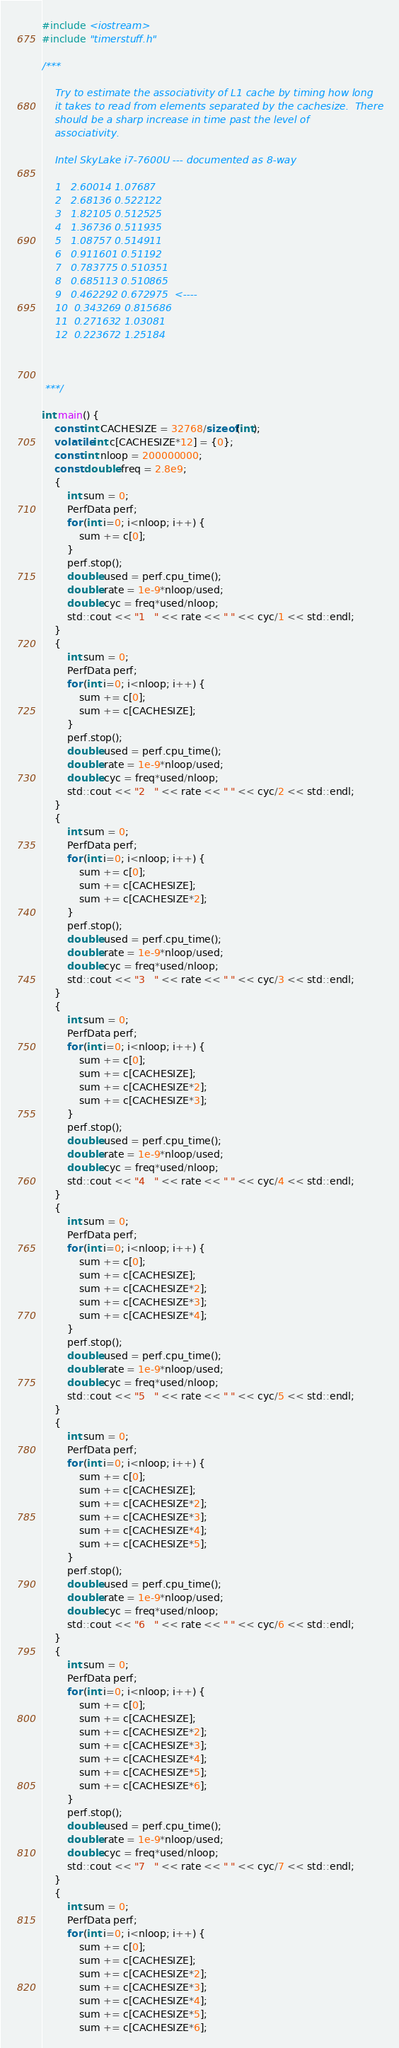Convert code to text. <code><loc_0><loc_0><loc_500><loc_500><_C++_>#include <iostream>
#include "timerstuff.h"

/***

    Try to estimate the associativity of L1 cache by timing how long
    it takes to read from elements separated by the cachesize.  There
    should be a sharp increase in time past the level of
    associativity.

    Intel SkyLake i7-7600U --- documented as 8-way

    1   2.60014 1.07687
    2   2.68136 0.522122
    3   1.82105 0.512525
    4   1.36736 0.511935
    5   1.08757 0.514911
    6   0.911601 0.51192
    7   0.783775 0.510351
    8   0.685113 0.510865
    9   0.462292 0.672975  <----
    10  0.343269 0.815686
    11  0.271632 1.03081
    12  0.223672 1.25184

    

 ***/

int main() {
    const int CACHESIZE = 32768/sizeof(int);
    volatile int c[CACHESIZE*12] = {0};
    const int nloop = 200000000;
    const double freq = 2.8e9;
    {
        int sum = 0;
        PerfData perf;
        for (int i=0; i<nloop; i++) {
            sum += c[0];
        }
        perf.stop();
        double used = perf.cpu_time();
        double rate = 1e-9*nloop/used;
        double cyc = freq*used/nloop;
        std::cout << "1   " << rate << " " << cyc/1 << std::endl;
    }
    {
        int sum = 0;
        PerfData perf;
        for (int i=0; i<nloop; i++) {
            sum += c[0];
            sum += c[CACHESIZE];
        }
        perf.stop();
        double used = perf.cpu_time();
        double rate = 1e-9*nloop/used;
        double cyc = freq*used/nloop;
        std::cout << "2   " << rate << " " << cyc/2 << std::endl;
    }
    {
        int sum = 0;
        PerfData perf;
        for (int i=0; i<nloop; i++) {
            sum += c[0];
            sum += c[CACHESIZE];
            sum += c[CACHESIZE*2];
        }
        perf.stop();
        double used = perf.cpu_time();
        double rate = 1e-9*nloop/used;
        double cyc = freq*used/nloop;
        std::cout << "3   " << rate << " " << cyc/3 << std::endl;
    }
    {
        int sum = 0;
        PerfData perf;
        for (int i=0; i<nloop; i++) {
            sum += c[0];
            sum += c[CACHESIZE];
            sum += c[CACHESIZE*2];
            sum += c[CACHESIZE*3];
        }
        perf.stop();
        double used = perf.cpu_time();
        double rate = 1e-9*nloop/used;
        double cyc = freq*used/nloop;
        std::cout << "4   " << rate << " " << cyc/4 << std::endl;
    }
    {
        int sum = 0;
        PerfData perf;
        for (int i=0; i<nloop; i++) {
            sum += c[0];
            sum += c[CACHESIZE];
            sum += c[CACHESIZE*2];
            sum += c[CACHESIZE*3];
            sum += c[CACHESIZE*4];
        }
        perf.stop();
        double used = perf.cpu_time();
        double rate = 1e-9*nloop/used;
        double cyc = freq*used/nloop;
        std::cout << "5   " << rate << " " << cyc/5 << std::endl;
    }
    {
        int sum = 0;
        PerfData perf;
        for (int i=0; i<nloop; i++) {
            sum += c[0];
            sum += c[CACHESIZE];
            sum += c[CACHESIZE*2];
            sum += c[CACHESIZE*3];
            sum += c[CACHESIZE*4];
            sum += c[CACHESIZE*5];
        }
        perf.stop();
        double used = perf.cpu_time();
        double rate = 1e-9*nloop/used;
        double cyc = freq*used/nloop;
        std::cout << "6   " << rate << " " << cyc/6 << std::endl;
    }
    {
        int sum = 0;
        PerfData perf;
        for (int i=0; i<nloop; i++) {
            sum += c[0];
            sum += c[CACHESIZE];
            sum += c[CACHESIZE*2];
            sum += c[CACHESIZE*3];
            sum += c[CACHESIZE*4];
            sum += c[CACHESIZE*5];
            sum += c[CACHESIZE*6];
        }
        perf.stop();
        double used = perf.cpu_time();
        double rate = 1e-9*nloop/used;
        double cyc = freq*used/nloop;
        std::cout << "7   " << rate << " " << cyc/7 << std::endl;
    }
    {
        int sum = 0;
        PerfData perf;
        for (int i=0; i<nloop; i++) {
            sum += c[0];
            sum += c[CACHESIZE];
            sum += c[CACHESIZE*2];
            sum += c[CACHESIZE*3];
            sum += c[CACHESIZE*4];
            sum += c[CACHESIZE*5];
            sum += c[CACHESIZE*6];</code> 